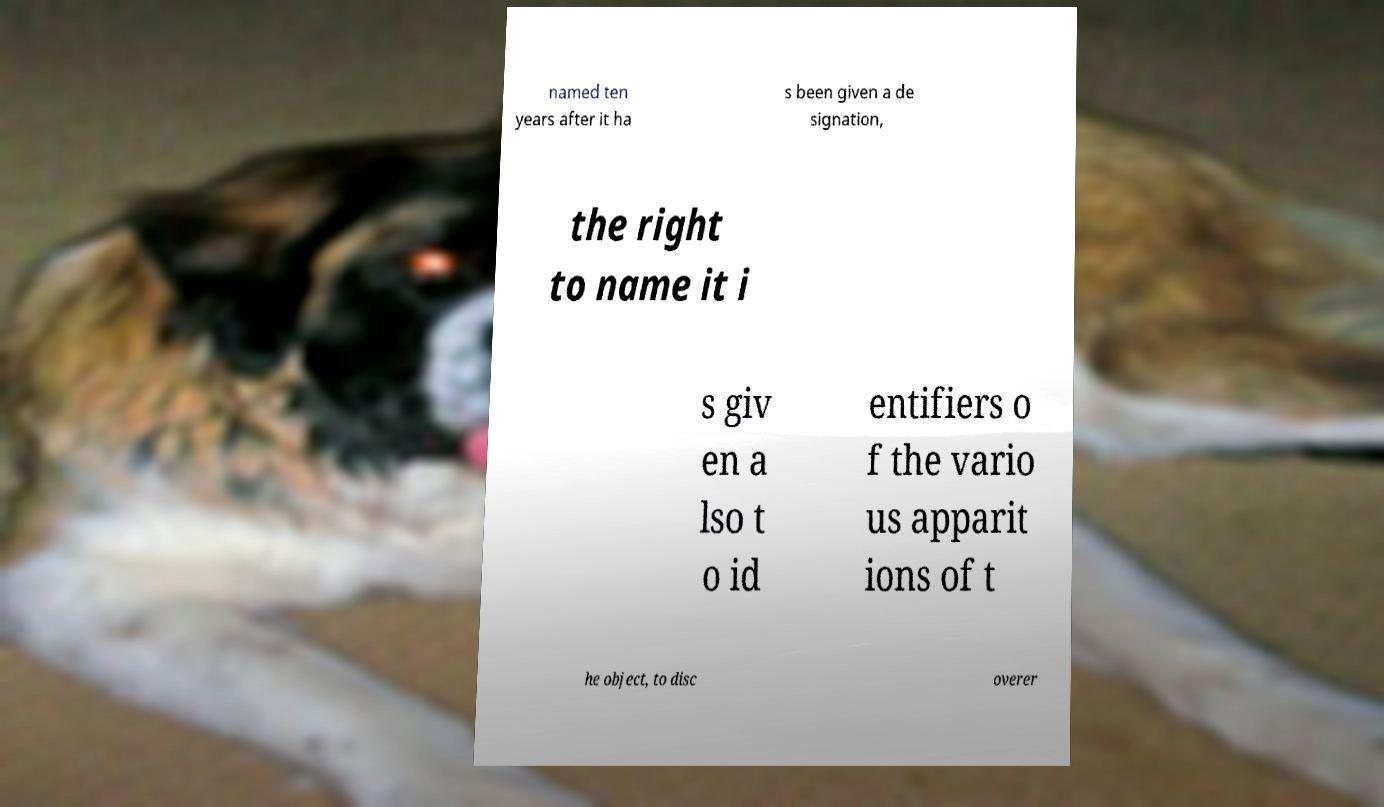Could you extract and type out the text from this image? named ten years after it ha s been given a de signation, the right to name it i s giv en a lso t o id entifiers o f the vario us apparit ions of t he object, to disc overer 